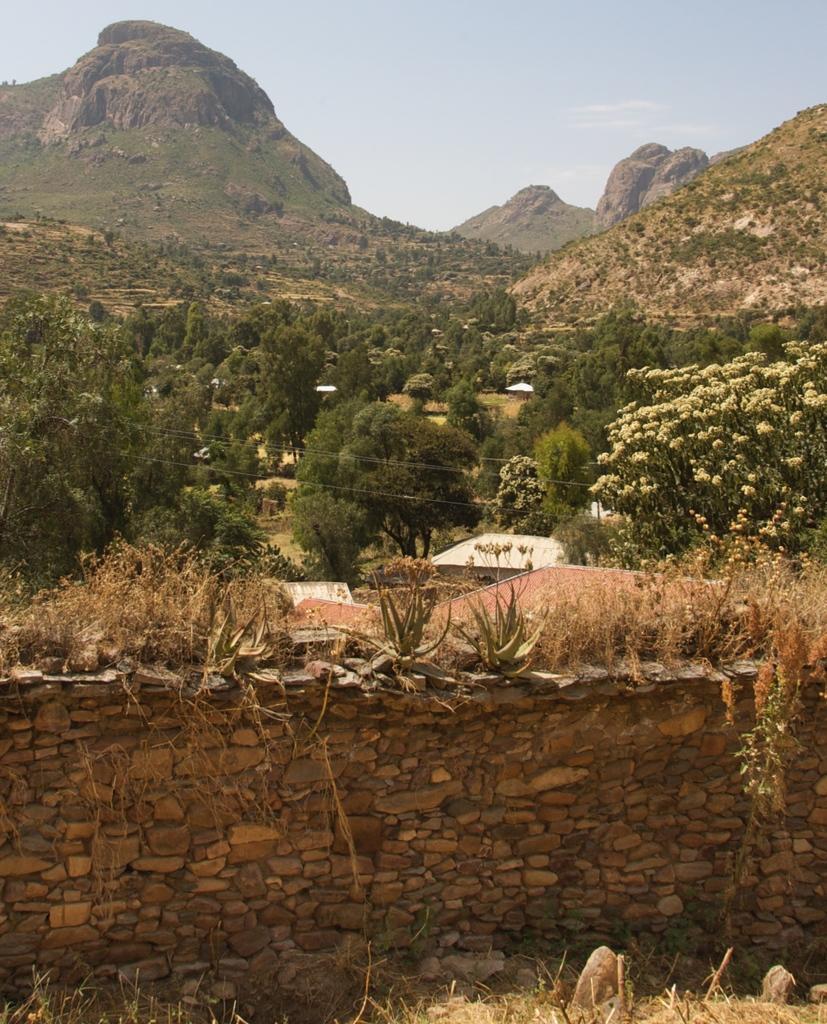Can you describe this image briefly? An outdoor picture. This wall is made with stones. Far there are number of trees. Mountains, hills. Sky is in blue color. Plants with flowers. 